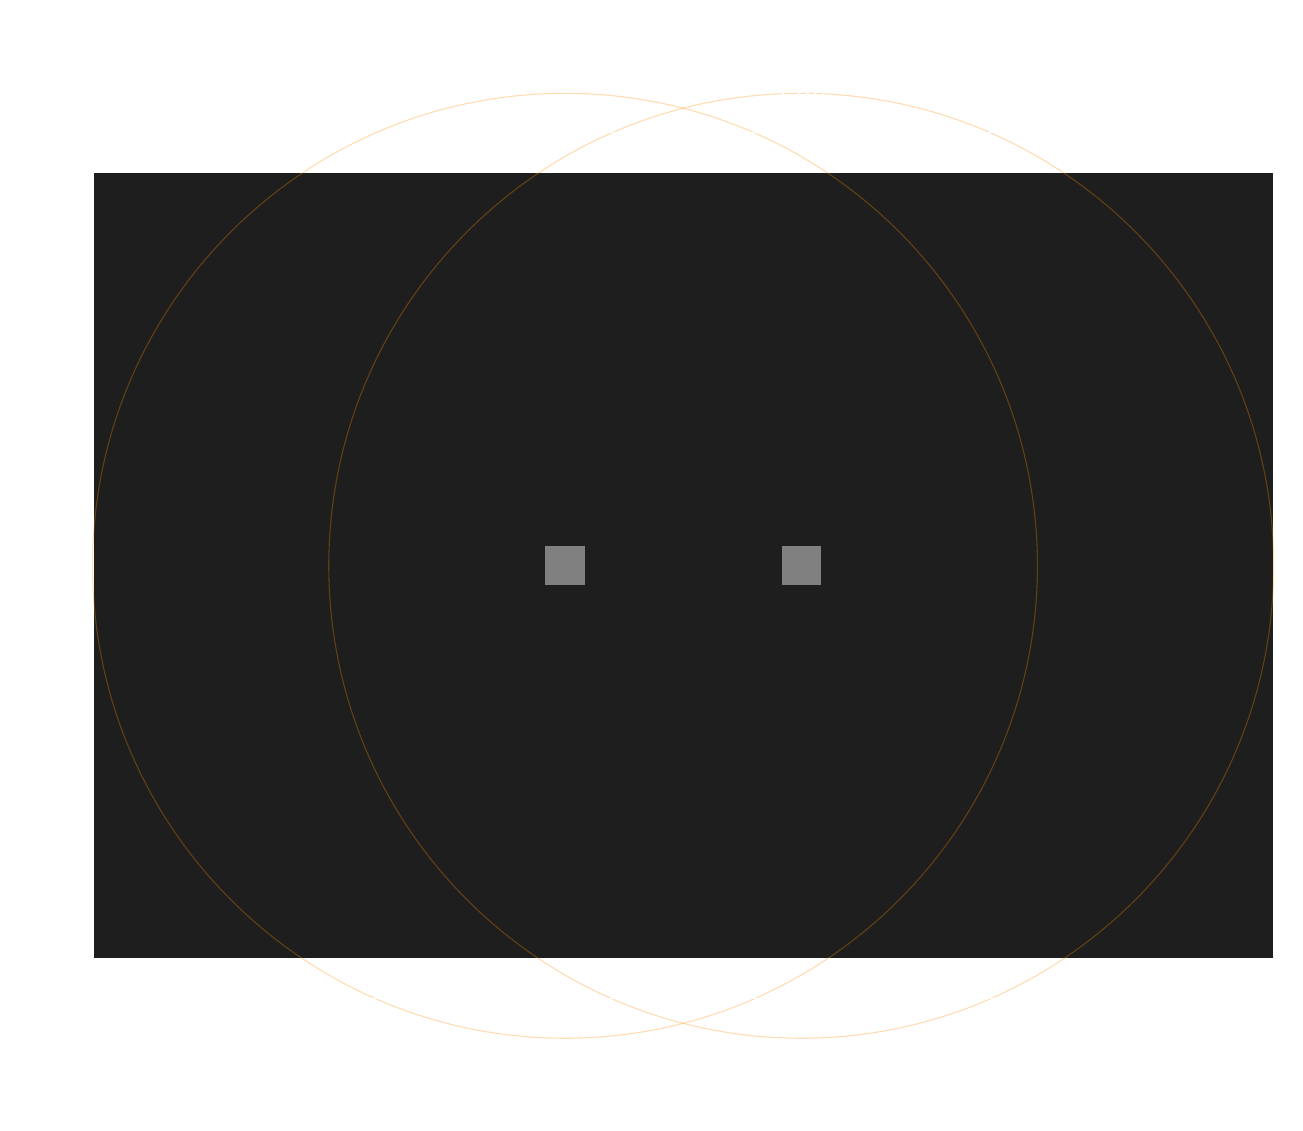What is the answer to this math problem? Let's break this down step-by-step:

1) First, calculate the total area of the club:
   $A_{club} = 30m \times 20m = 600m^2$

2) Now, calculate the area covered by each speaker:
   $A_{speaker} = \pi r^2 = \pi \times 12^2 = 144\pi m^2$

3) The total area covered by both speakers would be:
   $A_{total} = 2 \times 144\pi m^2 = 288\pi m^2$

4) However, the speakers' coverage areas overlap. We need to calculate this overlap area.
   The distance between the centers of the circles is 6m (18m - 12m).
   We can use the formula for the area of intersection of two circles:

   $A_{overlap} = 2r^2 \arccos(\frac{d}{2r}) - d\sqrt{r^2 - \frac{d^2}{4}}$

   Where $r = 12m$ and $d = 6m$

5) Plugging in the values:
   $A_{overlap} = 2 \times 12^2 \arccos(\frac{6}{2 \times 12}) - 6\sqrt{12^2 - \frac{6^2}{4}}$
   $= 288 \arccos(0.25) - 6\sqrt{144 - 9}$
   $\approx 288 \times 1.318 - 6 \times 11.66$
   $\approx 309.98m^2$

6) So, the actual area covered by sound is:
   $A_{covered} = A_{total} - A_{overlap}$
   $= 288\pi - 309.98 \approx 595.31m^2$

7) Calculate the percentage of the club covered:
   $Percentage = \frac{A_{covered}}{A_{club}} \times 100\%$
   $= \frac{595.31}{600} \times 100\% \approx 99.22\%$

8) Rounding to the nearest whole percent gives 99%.
Answer: 99% 